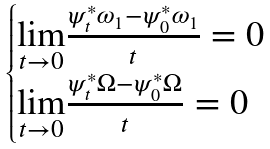Convert formula to latex. <formula><loc_0><loc_0><loc_500><loc_500>\begin{cases} \underset { t \rightarrow 0 } { \lim } \frac { \psi _ { t } ^ { * } \omega _ { 1 } - \psi _ { 0 } ^ { * } \omega _ { 1 } } { t } = 0 & \\ \underset { t \rightarrow 0 } { \lim } \frac { \psi _ { t } ^ { * } \Omega - \psi _ { 0 } ^ { * } \Omega } { t } = 0 & \\ \end{cases}</formula> 